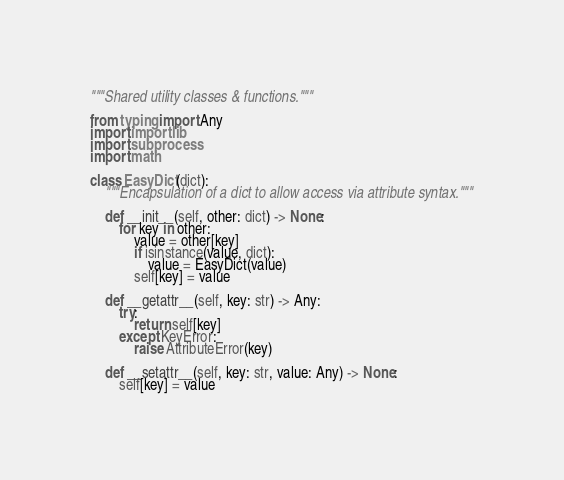<code> <loc_0><loc_0><loc_500><loc_500><_Python_>"""Shared utility classes & functions."""

from typing import Any
import importlib
import subprocess
import math

class EasyDict(dict):
    """Encapsulation of a dict to allow access via attribute syntax."""

    def __init__(self, other: dict) -> None:
        for key in other:
            value = other[key]
            if isinstance(value, dict):
                value = EasyDict(value)
            self[key] = value

    def __getattr__(self, key: str) -> Any:
        try:
            return self[key]
        except KeyError:
            raise AttributeError(key)

    def __setattr__(self, key: str, value: Any) -> None:
        self[key] = value
</code> 